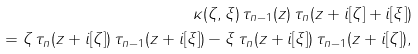<formula> <loc_0><loc_0><loc_500><loc_500>\kappa ( \zeta , \xi ) \, \tau _ { n - 1 } ( z ) \, \tau _ { n } ( z + i [ \zeta ] + i [ \xi ] ) \\ = \zeta \, \tau _ { n } ( z + i [ \zeta ] ) \, \tau _ { n - 1 } ( z + i [ \xi ] ) - \xi \, \tau _ { n } ( z + i [ \xi ] ) \, \tau _ { n - 1 } ( z + i [ \zeta ] ) ,</formula> 